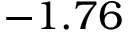Convert formula to latex. <formula><loc_0><loc_0><loc_500><loc_500>- 1 . 7 6</formula> 